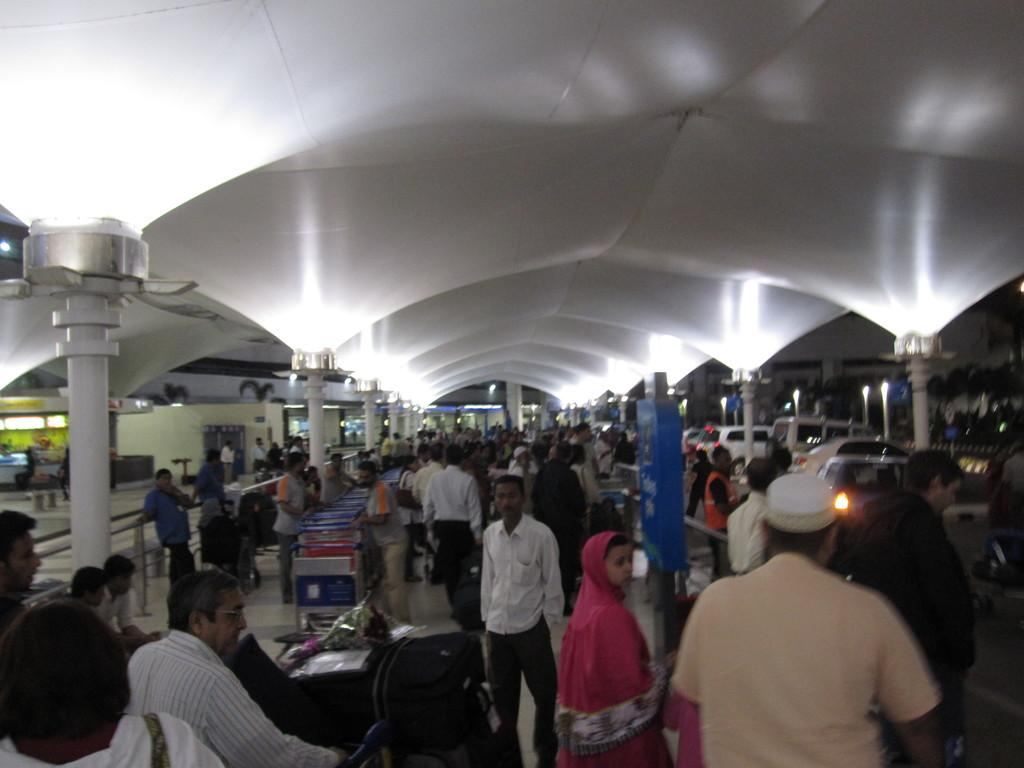How many people can be seen in the image? There are many people in the image. What are the people doing in the image? The people are standing with their luggage. What type of structure is providing shelter in the image? They are under a white roof. What can be seen on the right side of the image? There are vehicles on the road on the right side of the image. What type of animal can be seen playing with a faucet in the image? There is no animal or faucet present in the image. 